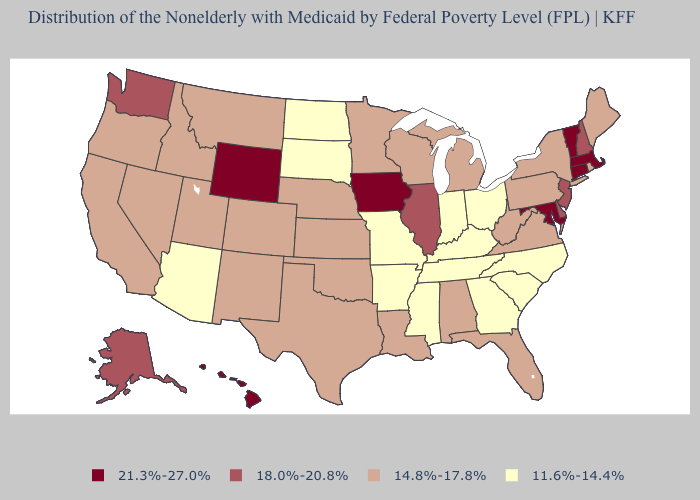What is the highest value in states that border Maryland?
Quick response, please. 18.0%-20.8%. What is the value of Pennsylvania?
Concise answer only. 14.8%-17.8%. Among the states that border Connecticut , which have the lowest value?
Be succinct. New York, Rhode Island. Name the states that have a value in the range 14.8%-17.8%?
Concise answer only. Alabama, California, Colorado, Florida, Idaho, Kansas, Louisiana, Maine, Michigan, Minnesota, Montana, Nebraska, Nevada, New Mexico, New York, Oklahoma, Oregon, Pennsylvania, Rhode Island, Texas, Utah, Virginia, West Virginia, Wisconsin. Does the first symbol in the legend represent the smallest category?
Concise answer only. No. What is the value of Connecticut?
Write a very short answer. 21.3%-27.0%. Does Illinois have the same value as Kentucky?
Short answer required. No. What is the value of South Carolina?
Write a very short answer. 11.6%-14.4%. What is the value of California?
Answer briefly. 14.8%-17.8%. Name the states that have a value in the range 14.8%-17.8%?
Concise answer only. Alabama, California, Colorado, Florida, Idaho, Kansas, Louisiana, Maine, Michigan, Minnesota, Montana, Nebraska, Nevada, New Mexico, New York, Oklahoma, Oregon, Pennsylvania, Rhode Island, Texas, Utah, Virginia, West Virginia, Wisconsin. What is the value of Connecticut?
Short answer required. 21.3%-27.0%. Does Washington have a lower value than Kentucky?
Answer briefly. No. Does the first symbol in the legend represent the smallest category?
Be succinct. No. What is the value of Hawaii?
Concise answer only. 21.3%-27.0%. 